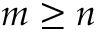<formula> <loc_0><loc_0><loc_500><loc_500>m \geq n</formula> 